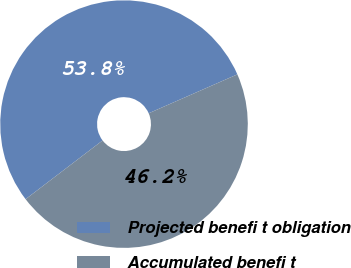Convert chart. <chart><loc_0><loc_0><loc_500><loc_500><pie_chart><fcel>Projected benefi t obligation<fcel>Accumulated benefi t<nl><fcel>53.79%<fcel>46.21%<nl></chart> 